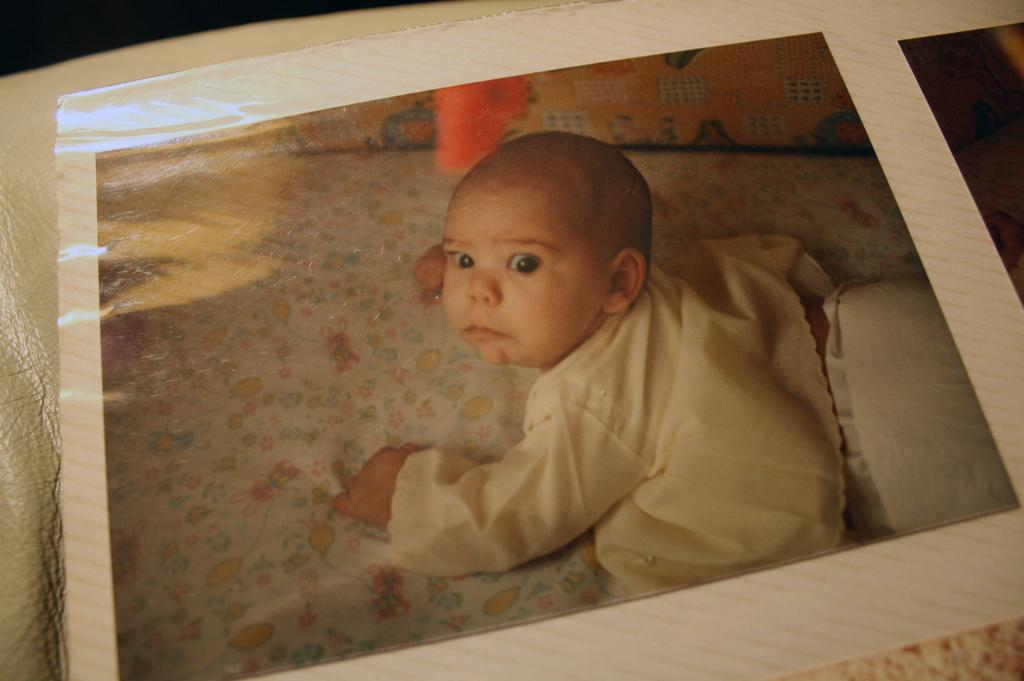What is the main subject of the image? There is a photograph of a baby in the image. What position is the baby in? The baby is lying down. What is the baby wearing in the image? The baby is wearing clothes. What type of iron is the baby using in the image? There is no iron present in the image; the baby is simply lying down and wearing clothes. 